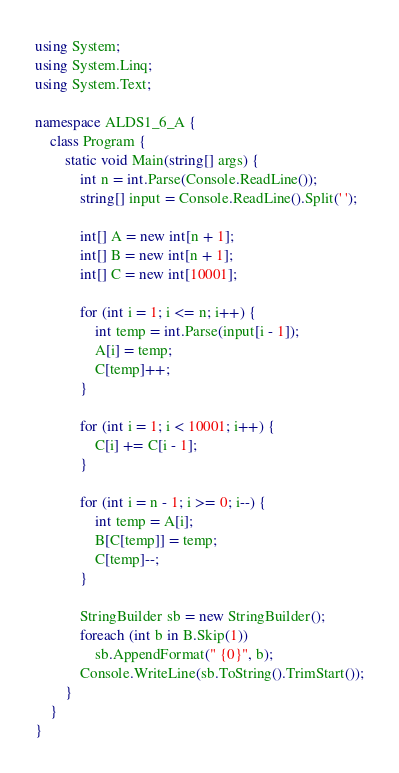<code> <loc_0><loc_0><loc_500><loc_500><_C#_>using System;
using System.Linq;
using System.Text;

namespace ALDS1_6_A {
    class Program {
        static void Main(string[] args) {
            int n = int.Parse(Console.ReadLine());
            string[] input = Console.ReadLine().Split(' ');

            int[] A = new int[n + 1];
            int[] B = new int[n + 1];
            int[] C = new int[10001];

            for (int i = 1; i <= n; i++) {
                int temp = int.Parse(input[i - 1]);
                A[i] = temp;
                C[temp]++;
            }

            for (int i = 1; i < 10001; i++) {
                C[i] += C[i - 1];
            }

            for (int i = n - 1; i >= 0; i--) {
                int temp = A[i];
                B[C[temp]] = temp;
                C[temp]--;
            }

            StringBuilder sb = new StringBuilder();
            foreach (int b in B.Skip(1))
                sb.AppendFormat(" {0}", b);
            Console.WriteLine(sb.ToString().TrimStart());
        }
    }
}</code> 